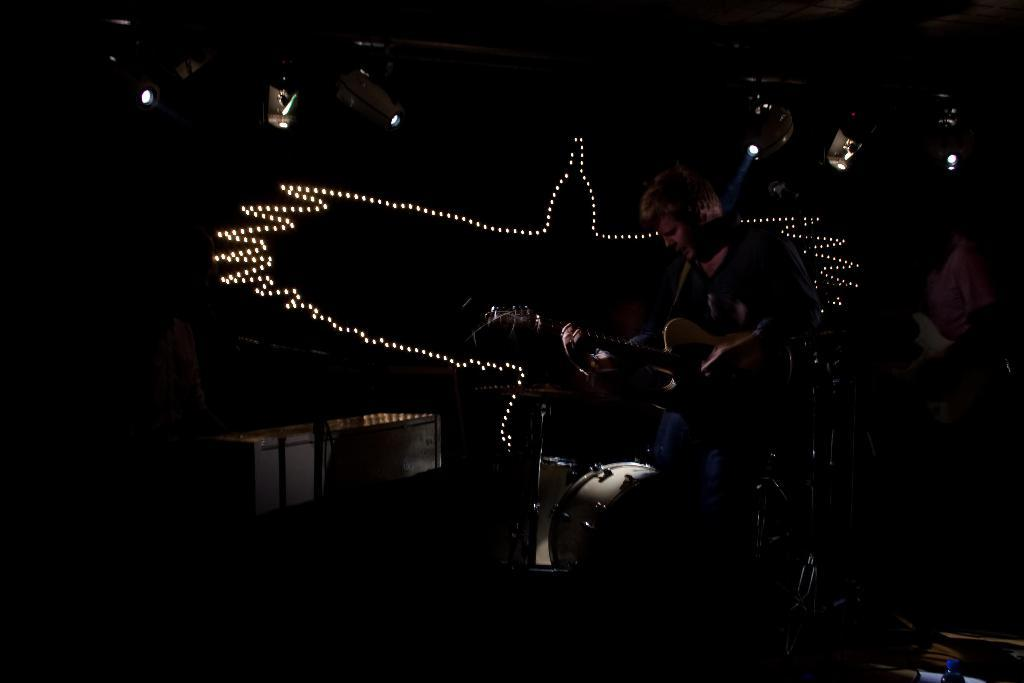What is the person in the image doing? The person is playing a guitar. What else can be seen in the image besides the person playing the guitar? There are musical instruments and focusing lights in the image. What type of pets are visible in the image? There are no pets visible in the image. What is the relation between the person playing the guitar and the musical instruments in the image? The person playing the guitar is likely using the other musical instruments in the image as part of their performance or practice. However, the exact relationship between the person and the instruments cannot be determined from the image alone. 